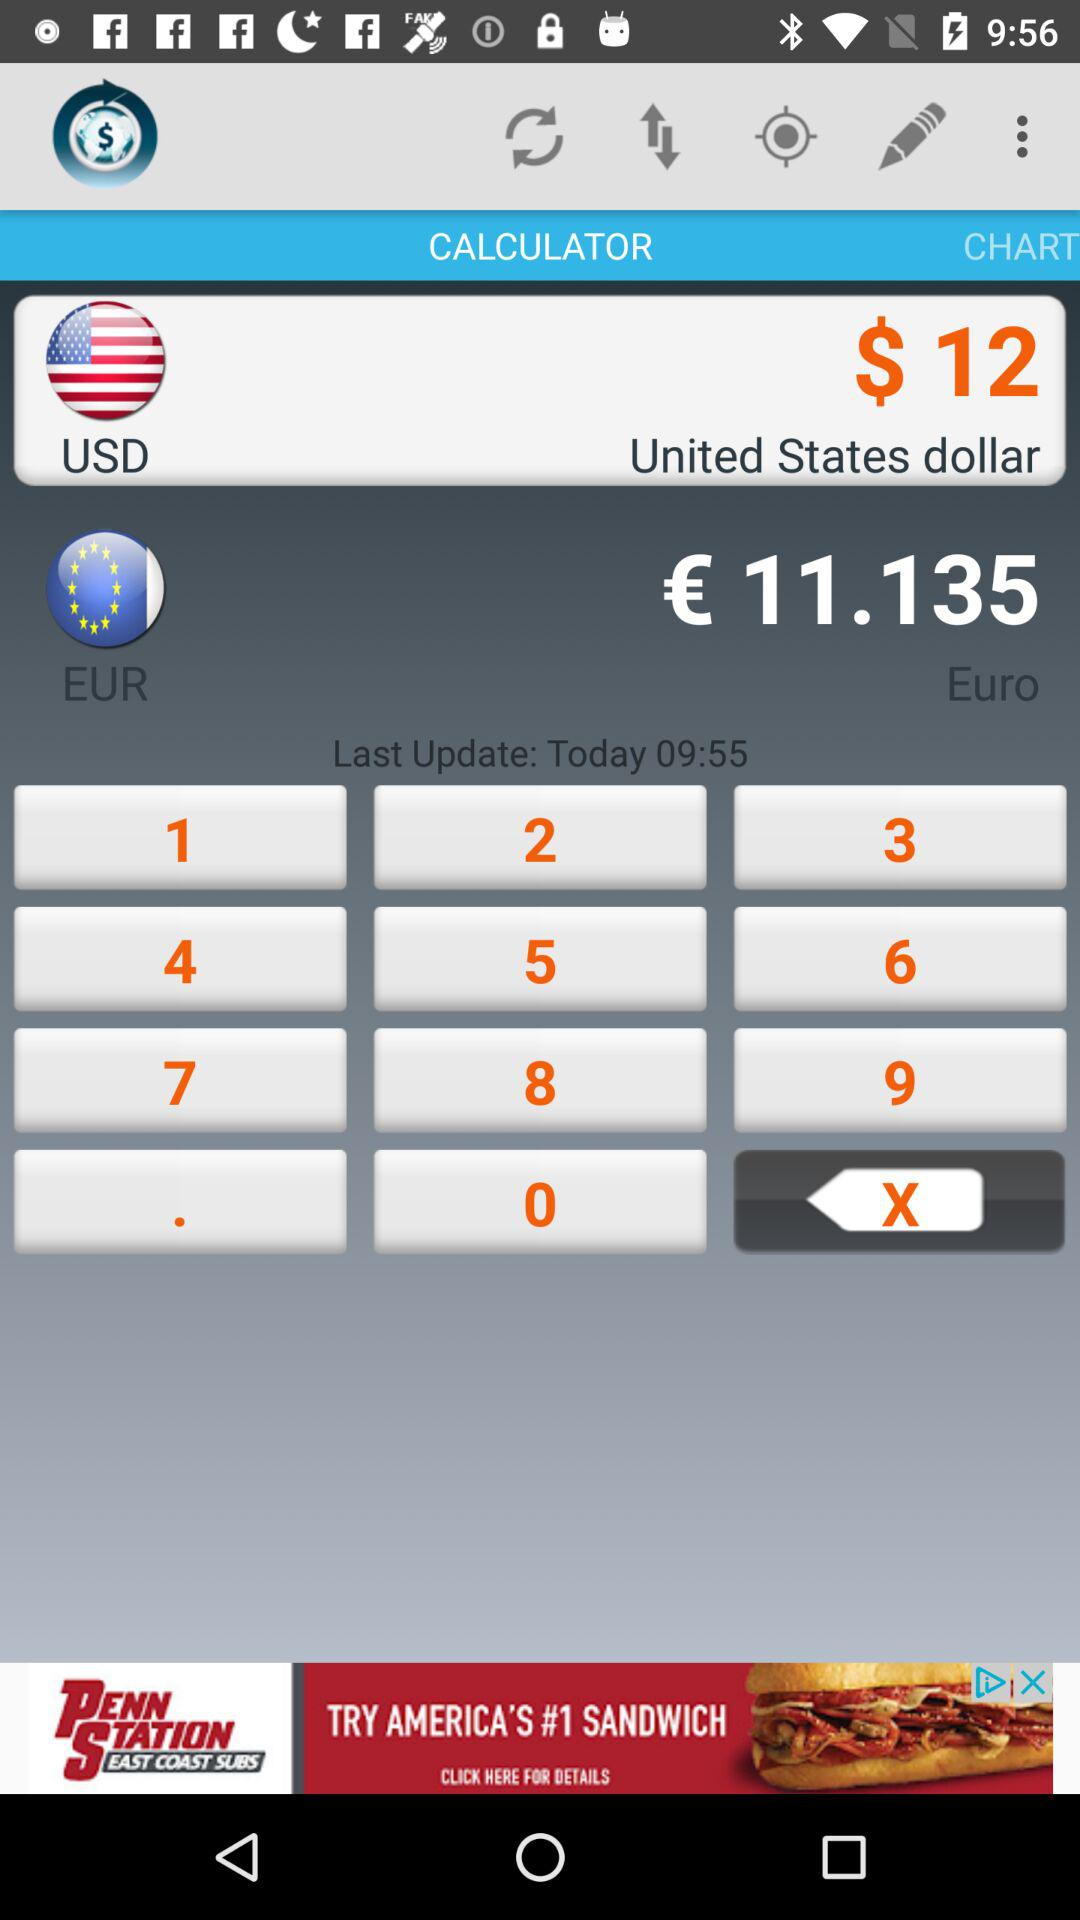When was the most recent update done? The most recent update was done today at 9:55. 